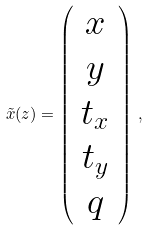<formula> <loc_0><loc_0><loc_500><loc_500>\tilde { x } ( z ) = \left ( \begin{array} { c } x \\ y \\ t _ { x } \\ t _ { y } \\ q \end{array} \right ) \, ,</formula> 